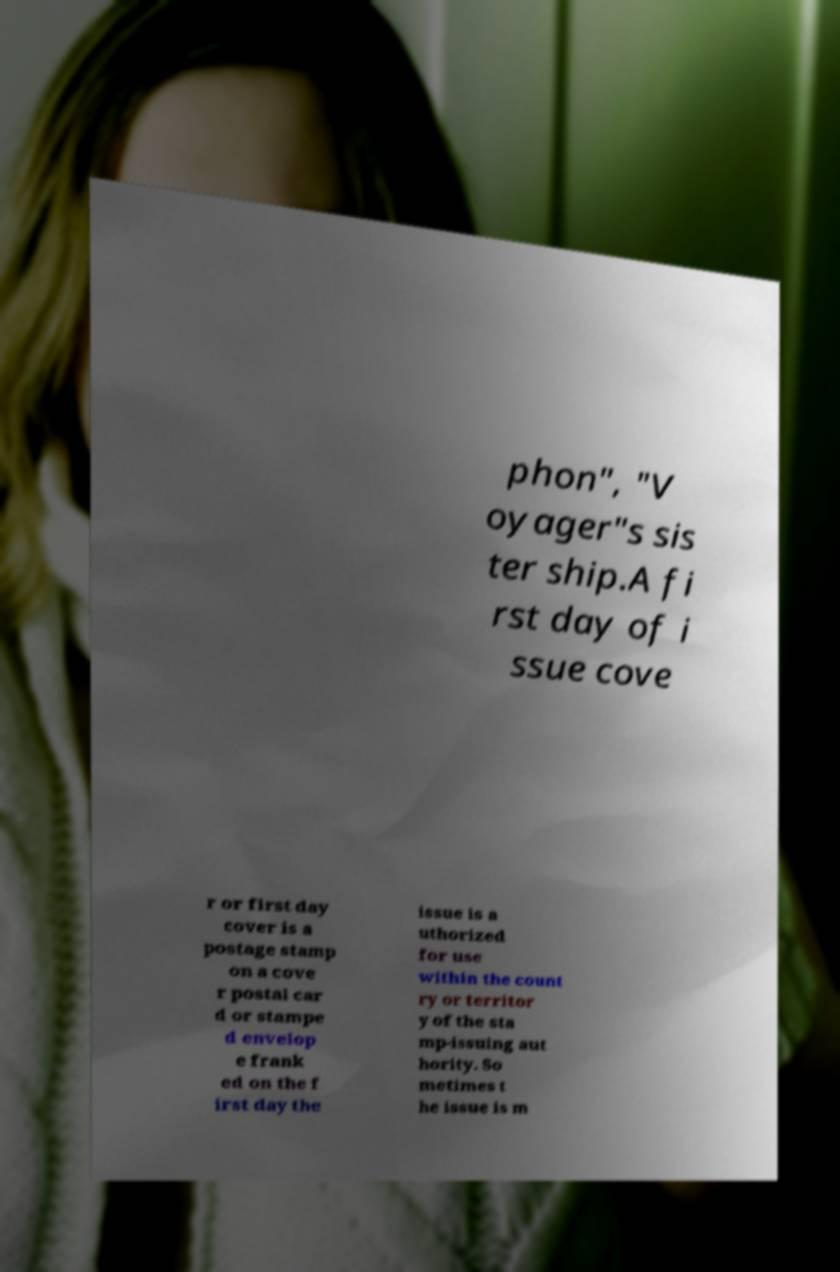Can you read and provide the text displayed in the image?This photo seems to have some interesting text. Can you extract and type it out for me? phon", "V oyager"s sis ter ship.A fi rst day of i ssue cove r or first day cover is a postage stamp on a cove r postal car d or stampe d envelop e frank ed on the f irst day the issue is a uthorized for use within the count ry or territor y of the sta mp-issuing aut hority. So metimes t he issue is m 